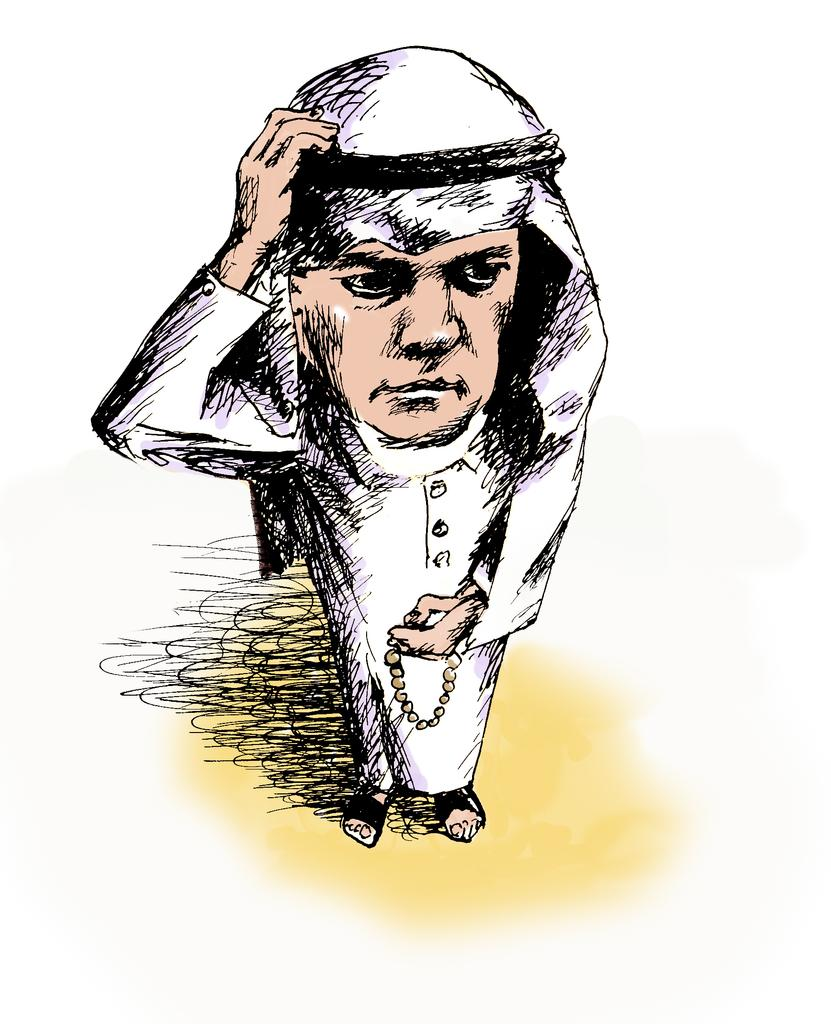What is the main subject of the image? The main subject of the image is a sketch of a person. What is the person in the sketch wearing? The person in the sketch is wearing a white dress. What color is the background of the image? The background of the image is white. How many sisters does the person in the sketch have, and what are their names? There is no information about the person's sisters in the image, so we cannot determine their names or number. 